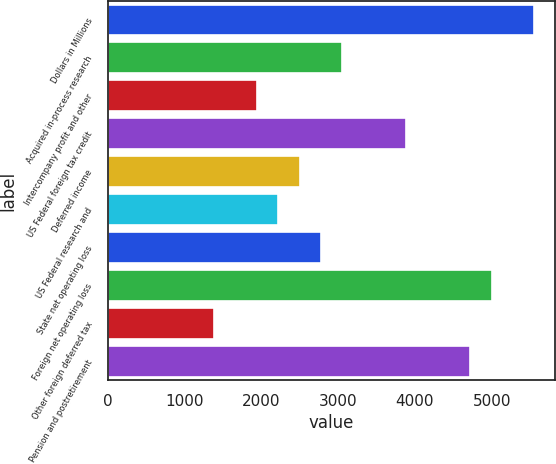Convert chart to OTSL. <chart><loc_0><loc_0><loc_500><loc_500><bar_chart><fcel>Dollars in Millions<fcel>Acquired in-process research<fcel>Intercompany profit and other<fcel>US Federal foreign tax credit<fcel>Deferred income<fcel>US Federal research and<fcel>State net operating loss<fcel>Foreign net operating loss<fcel>Other foreign deferred tax<fcel>Pension and postretirement<nl><fcel>5553<fcel>3055.5<fcel>1945.5<fcel>3888<fcel>2500.5<fcel>2223<fcel>2778<fcel>4998<fcel>1390.5<fcel>4720.5<nl></chart> 